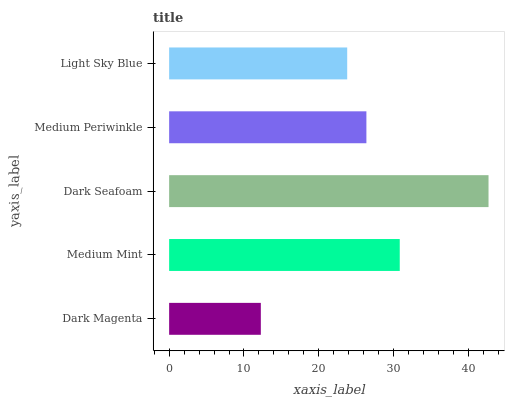Is Dark Magenta the minimum?
Answer yes or no. Yes. Is Dark Seafoam the maximum?
Answer yes or no. Yes. Is Medium Mint the minimum?
Answer yes or no. No. Is Medium Mint the maximum?
Answer yes or no. No. Is Medium Mint greater than Dark Magenta?
Answer yes or no. Yes. Is Dark Magenta less than Medium Mint?
Answer yes or no. Yes. Is Dark Magenta greater than Medium Mint?
Answer yes or no. No. Is Medium Mint less than Dark Magenta?
Answer yes or no. No. Is Medium Periwinkle the high median?
Answer yes or no. Yes. Is Medium Periwinkle the low median?
Answer yes or no. Yes. Is Dark Magenta the high median?
Answer yes or no. No. Is Light Sky Blue the low median?
Answer yes or no. No. 